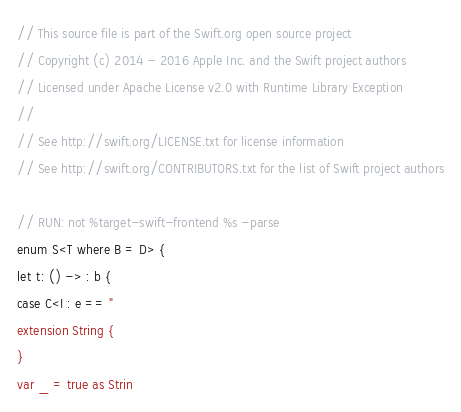<code> <loc_0><loc_0><loc_500><loc_500><_Swift_>// This source file is part of the Swift.org open source project
// Copyright (c) 2014 - 2016 Apple Inc. and the Swift project authors
// Licensed under Apache License v2.0 with Runtime Library Exception
//
// See http://swift.org/LICENSE.txt for license information
// See http://swift.org/CONTRIBUTORS.txt for the list of Swift project authors

// RUN: not %target-swift-frontend %s -parse
enum S<T where B = D> {
let t: () -> : b {
case C<I : e == "
extension String {
}
var _ = true as Strin
</code> 